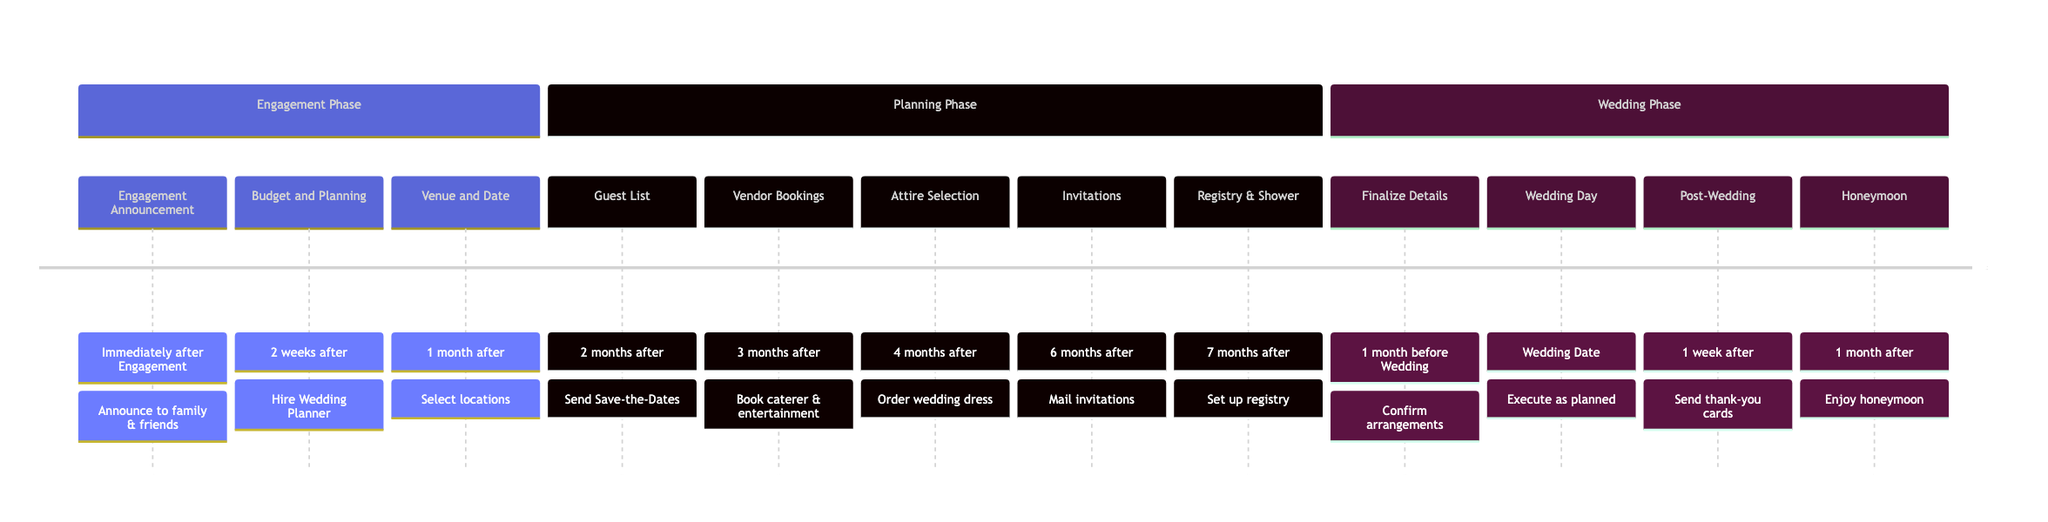What's the first milestone in the timeline? The first milestone is "Engagement Announcement," which occurs immediately after engagement.
Answer: Engagement Announcement How many months are there between the "Budget and Planning Meeting" and the "Wedding Day"? The "Budget and Planning Meeting" is set for 2 weeks after engagement, while the "Wedding Day" occurs on the wedding date. The timeline spans approximately 8 months until the wedding, making it just under 1 month from the planning meeting to the wedding.
Answer: Approximately 8 months What is the deadline for "Vendor Bookings"? "Vendor Bookings" must be completed 3 months after Engagement.
Answer: 3 months after Engagement Which milestone involves sending thank-you cards? The milestone that involves sending thank-you cards is "Post-Wedding Follow Up," which occurs 1 week after the wedding.
Answer: Post-Wedding Follow Up What task is associated with the "Venue and Date Selection"? The key task associated with "Venue and Date Selection" is to "Select ceremony and reception locations."
Answer: Select ceremony and reception locations What is the last milestone before the honeymoon? The last milestone before the honeymoon is the "Wedding Day," which occurs on the wedding date.
Answer: Wedding Day What task needs to be completed 6 months after engagement? The task to be completed 6 months after engagement is to "Mail invitations."
Answer: Mail invitations How many key tasks are there for "Attire Selection"? For "Attire Selection," there are three key tasks: choose the wedding dress, select tuxedos, and coordinate bridal party attire.
Answer: 3 key tasks Which vendor is involved in the "Vendor Bookings"? The vendor involved in "Vendor Bookings" could be the caterer, photographer, or entertainment such as a band.
Answer: Caterer, photographer, or entertainment 